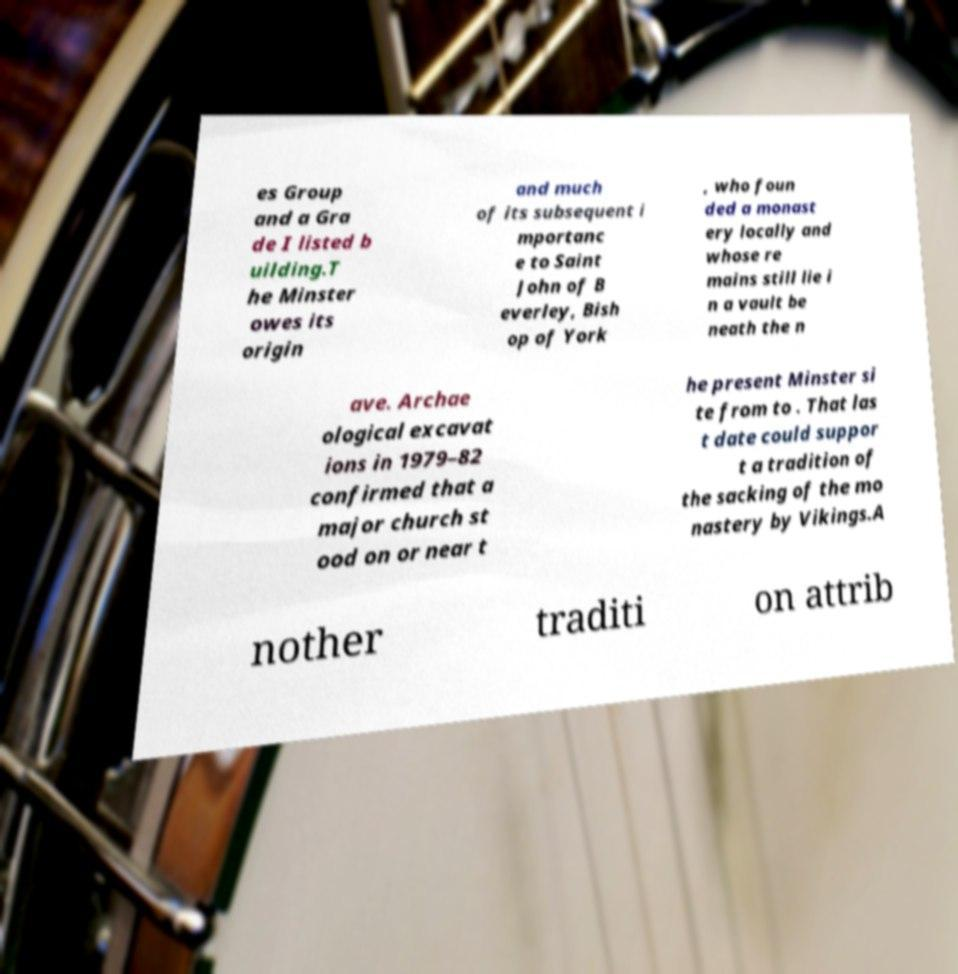I need the written content from this picture converted into text. Can you do that? es Group and a Gra de I listed b uilding.T he Minster owes its origin and much of its subsequent i mportanc e to Saint John of B everley, Bish op of York , who foun ded a monast ery locally and whose re mains still lie i n a vault be neath the n ave. Archae ological excavat ions in 1979–82 confirmed that a major church st ood on or near t he present Minster si te from to . That las t date could suppor t a tradition of the sacking of the mo nastery by Vikings.A nother traditi on attrib 